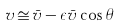Convert formula to latex. <formula><loc_0><loc_0><loc_500><loc_500>v \, \cong \, \bar { v } - \epsilon \bar { v } \cos \theta</formula> 